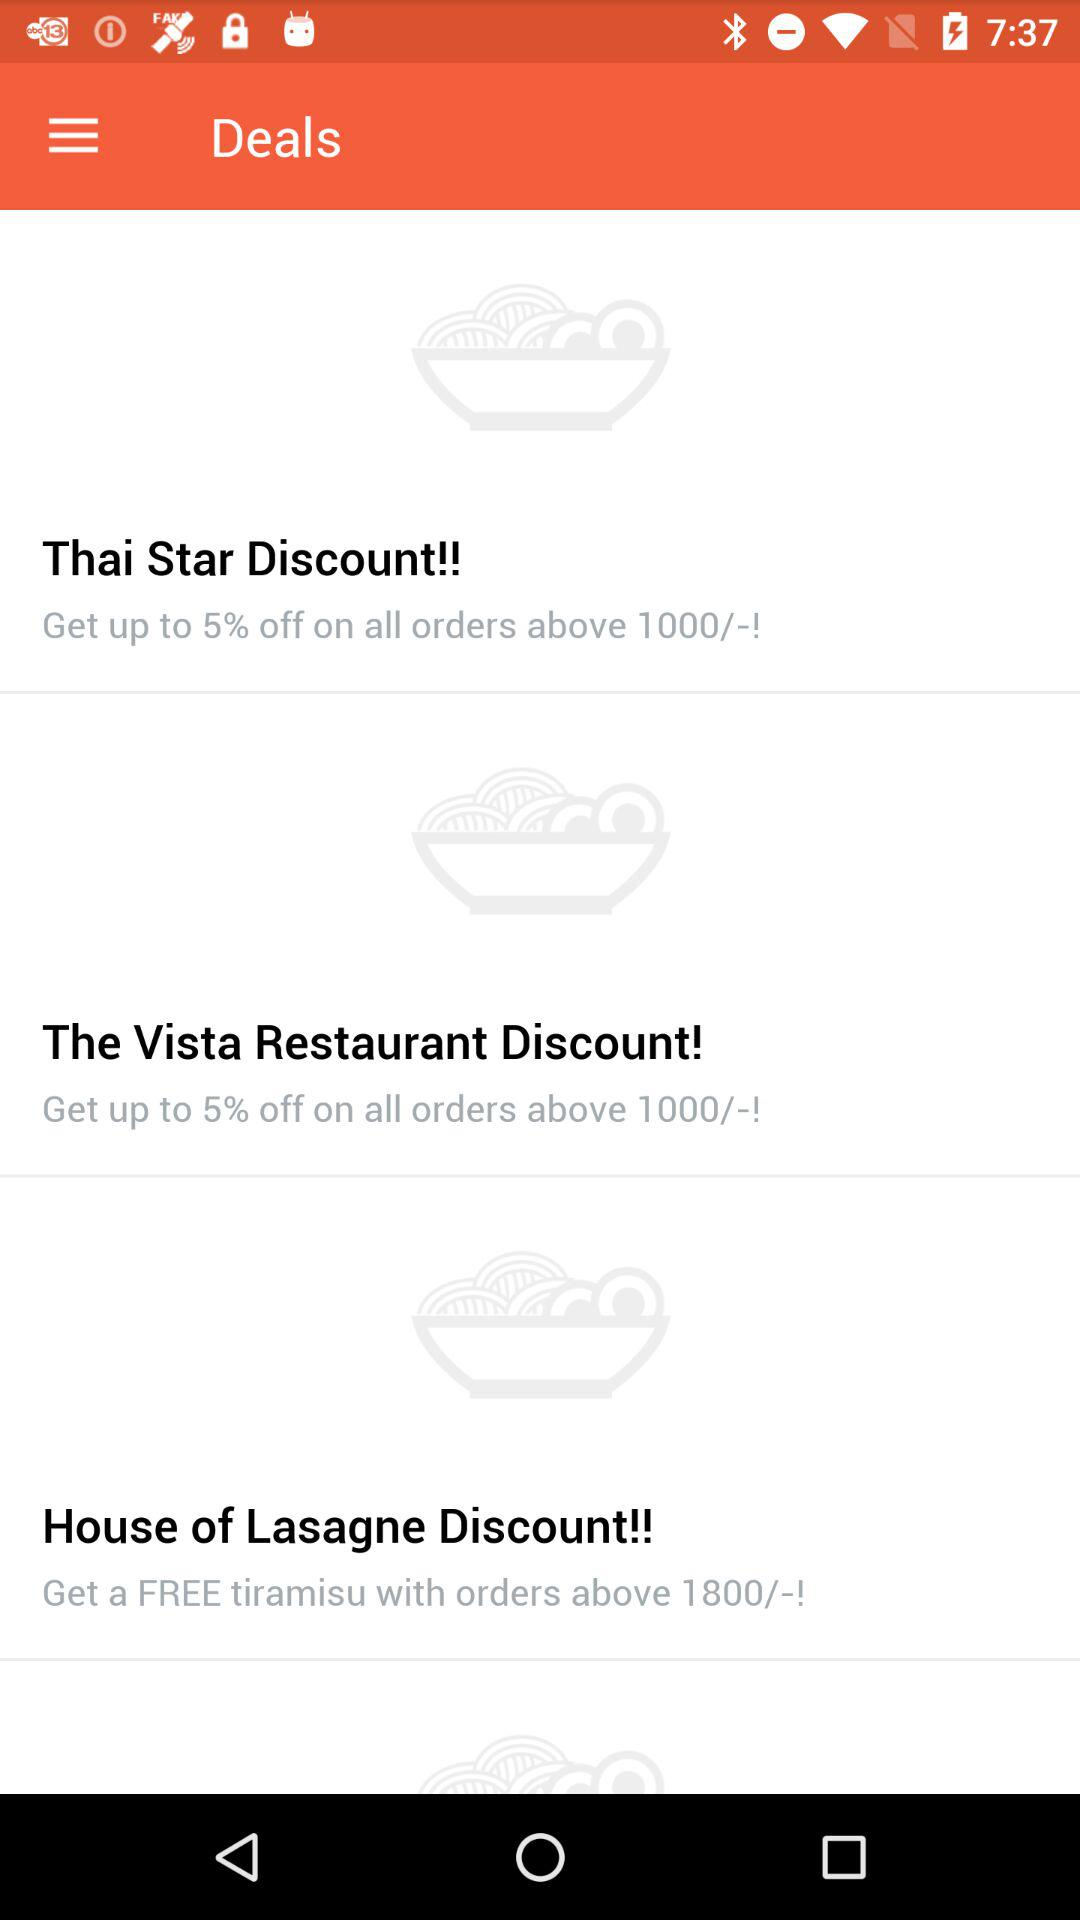How many deals are there?
Answer the question using a single word or phrase. 3 